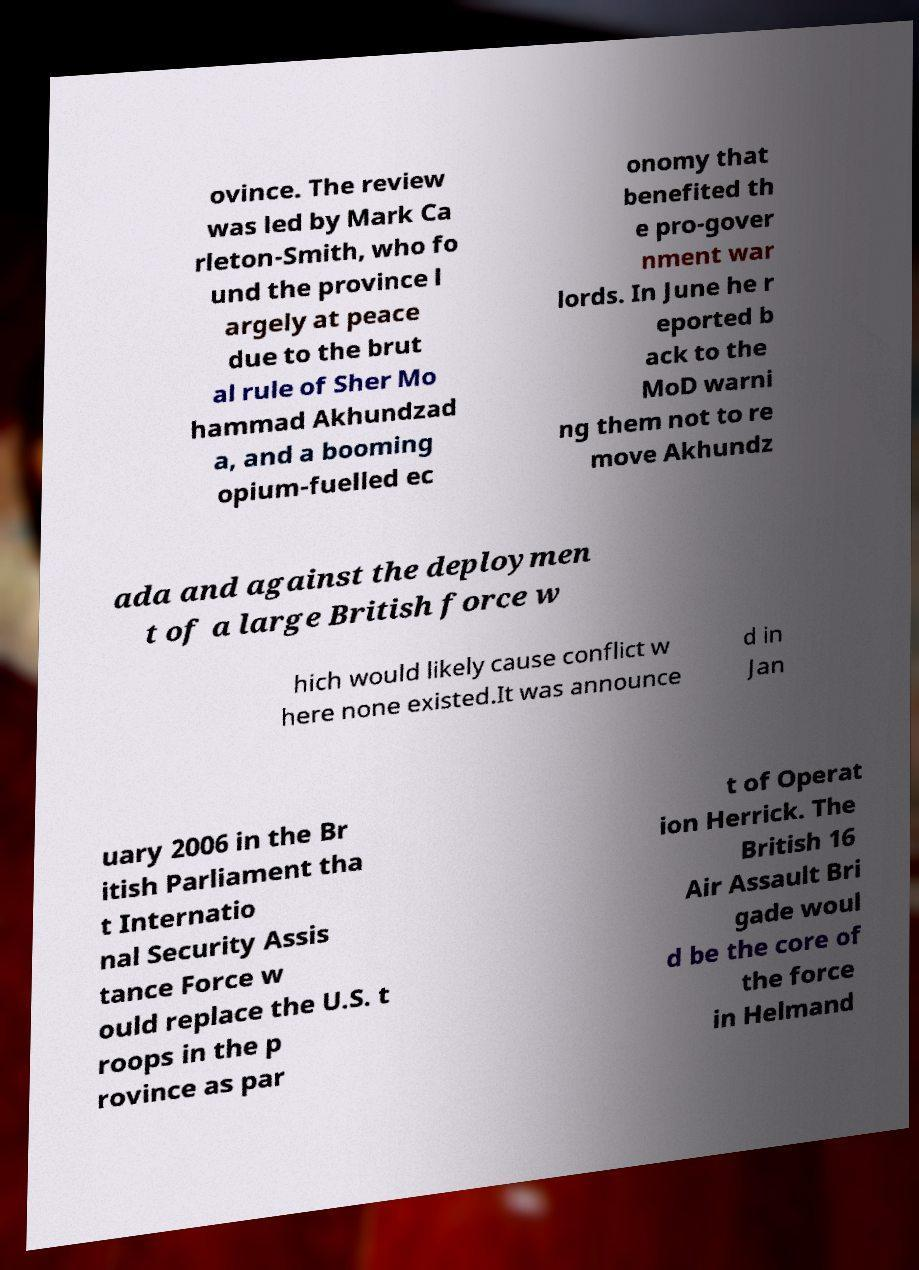I need the written content from this picture converted into text. Can you do that? ovince. The review was led by Mark Ca rleton-Smith, who fo und the province l argely at peace due to the brut al rule of Sher Mo hammad Akhundzad a, and a booming opium-fuelled ec onomy that benefited th e pro-gover nment war lords. In June he r eported b ack to the MoD warni ng them not to re move Akhundz ada and against the deploymen t of a large British force w hich would likely cause conflict w here none existed.It was announce d in Jan uary 2006 in the Br itish Parliament tha t Internatio nal Security Assis tance Force w ould replace the U.S. t roops in the p rovince as par t of Operat ion Herrick. The British 16 Air Assault Bri gade woul d be the core of the force in Helmand 